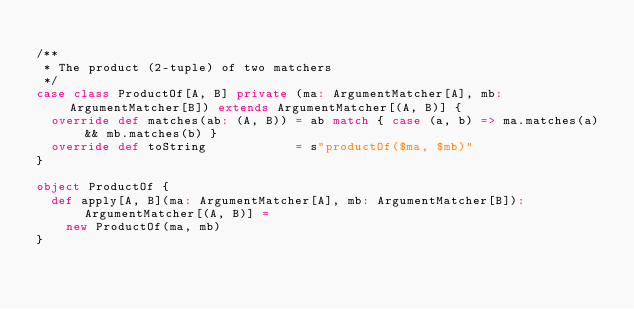Convert code to text. <code><loc_0><loc_0><loc_500><loc_500><_Scala_>
/**
 * The product (2-tuple) of two matchers
 */
case class ProductOf[A, B] private (ma: ArgumentMatcher[A], mb: ArgumentMatcher[B]) extends ArgumentMatcher[(A, B)] {
  override def matches(ab: (A, B)) = ab match { case (a, b) => ma.matches(a) && mb.matches(b) }
  override def toString            = s"productOf($ma, $mb)"
}

object ProductOf {
  def apply[A, B](ma: ArgumentMatcher[A], mb: ArgumentMatcher[B]): ArgumentMatcher[(A, B)] =
    new ProductOf(ma, mb)
}
</code> 